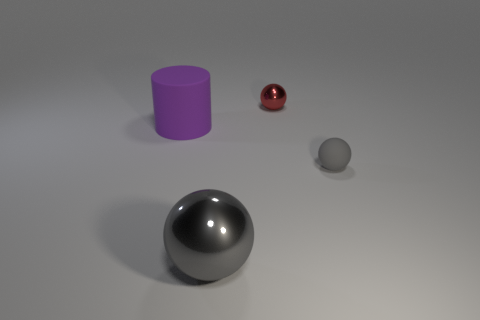Add 2 blue metal spheres. How many objects exist? 6 Subtract all spheres. How many objects are left? 1 Add 1 matte spheres. How many matte spheres exist? 2 Subtract 0 yellow cylinders. How many objects are left? 4 Subtract all green rubber spheres. Subtract all purple cylinders. How many objects are left? 3 Add 4 purple rubber cylinders. How many purple rubber cylinders are left? 5 